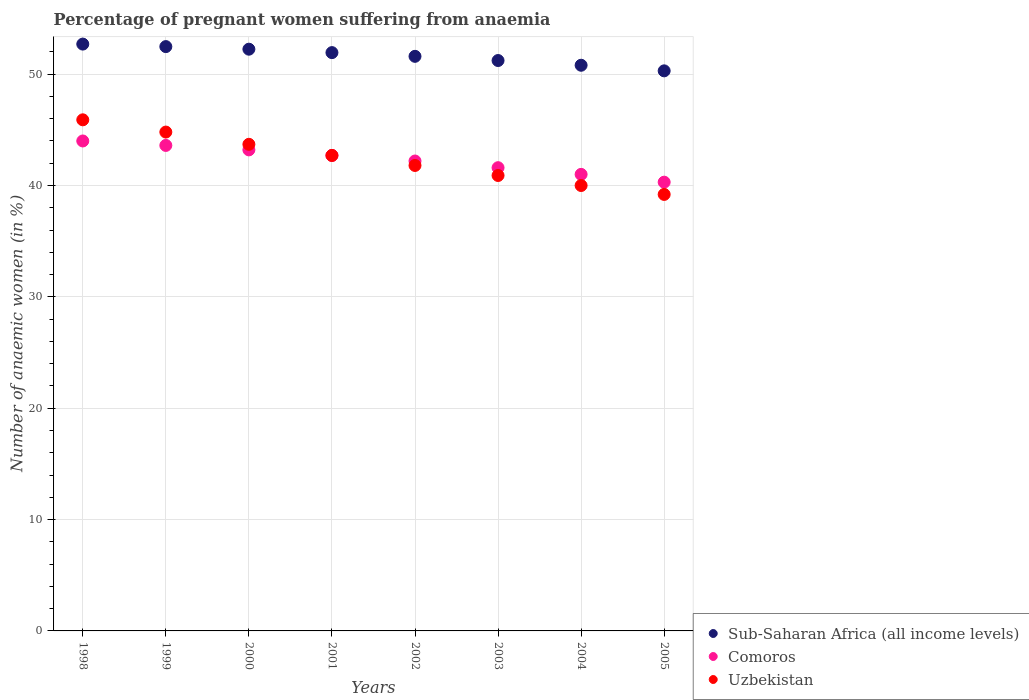What is the number of anaemic women in Comoros in 2005?
Your response must be concise. 40.3. Across all years, what is the maximum number of anaemic women in Sub-Saharan Africa (all income levels)?
Offer a very short reply. 52.7. Across all years, what is the minimum number of anaemic women in Sub-Saharan Africa (all income levels)?
Your answer should be compact. 50.3. In which year was the number of anaemic women in Comoros maximum?
Your response must be concise. 1998. What is the total number of anaemic women in Comoros in the graph?
Keep it short and to the point. 338.6. What is the difference between the number of anaemic women in Sub-Saharan Africa (all income levels) in 1999 and that in 2003?
Offer a terse response. 1.25. What is the difference between the number of anaemic women in Uzbekistan in 2003 and the number of anaemic women in Comoros in 2001?
Give a very brief answer. -1.8. What is the average number of anaemic women in Comoros per year?
Give a very brief answer. 42.33. What is the ratio of the number of anaemic women in Sub-Saharan Africa (all income levels) in 1998 to that in 1999?
Make the answer very short. 1. Is the difference between the number of anaemic women in Comoros in 1999 and 2002 greater than the difference between the number of anaemic women in Uzbekistan in 1999 and 2002?
Your response must be concise. No. What is the difference between the highest and the second highest number of anaemic women in Comoros?
Your answer should be very brief. 0.4. What is the difference between the highest and the lowest number of anaemic women in Comoros?
Offer a very short reply. 3.7. In how many years, is the number of anaemic women in Sub-Saharan Africa (all income levels) greater than the average number of anaemic women in Sub-Saharan Africa (all income levels) taken over all years?
Give a very brief answer. 4. Is it the case that in every year, the sum of the number of anaemic women in Sub-Saharan Africa (all income levels) and number of anaemic women in Uzbekistan  is greater than the number of anaemic women in Comoros?
Your answer should be compact. Yes. Does the number of anaemic women in Comoros monotonically increase over the years?
Offer a terse response. No. Is the number of anaemic women in Uzbekistan strictly less than the number of anaemic women in Comoros over the years?
Your answer should be compact. No. How many dotlines are there?
Offer a terse response. 3. How many years are there in the graph?
Give a very brief answer. 8. What is the difference between two consecutive major ticks on the Y-axis?
Provide a short and direct response. 10. Are the values on the major ticks of Y-axis written in scientific E-notation?
Make the answer very short. No. What is the title of the graph?
Your answer should be compact. Percentage of pregnant women suffering from anaemia. What is the label or title of the X-axis?
Provide a short and direct response. Years. What is the label or title of the Y-axis?
Offer a very short reply. Number of anaemic women (in %). What is the Number of anaemic women (in %) of Sub-Saharan Africa (all income levels) in 1998?
Provide a succinct answer. 52.7. What is the Number of anaemic women (in %) in Comoros in 1998?
Your response must be concise. 44. What is the Number of anaemic women (in %) in Uzbekistan in 1998?
Make the answer very short. 45.9. What is the Number of anaemic women (in %) in Sub-Saharan Africa (all income levels) in 1999?
Provide a short and direct response. 52.47. What is the Number of anaemic women (in %) in Comoros in 1999?
Your answer should be compact. 43.6. What is the Number of anaemic women (in %) of Uzbekistan in 1999?
Your answer should be very brief. 44.8. What is the Number of anaemic women (in %) of Sub-Saharan Africa (all income levels) in 2000?
Your response must be concise. 52.24. What is the Number of anaemic women (in %) of Comoros in 2000?
Your answer should be compact. 43.2. What is the Number of anaemic women (in %) of Uzbekistan in 2000?
Offer a terse response. 43.7. What is the Number of anaemic women (in %) in Sub-Saharan Africa (all income levels) in 2001?
Ensure brevity in your answer.  51.93. What is the Number of anaemic women (in %) of Comoros in 2001?
Give a very brief answer. 42.7. What is the Number of anaemic women (in %) of Uzbekistan in 2001?
Your response must be concise. 42.7. What is the Number of anaemic women (in %) of Sub-Saharan Africa (all income levels) in 2002?
Offer a very short reply. 51.6. What is the Number of anaemic women (in %) in Comoros in 2002?
Provide a short and direct response. 42.2. What is the Number of anaemic women (in %) of Uzbekistan in 2002?
Your response must be concise. 41.8. What is the Number of anaemic women (in %) of Sub-Saharan Africa (all income levels) in 2003?
Your answer should be very brief. 51.22. What is the Number of anaemic women (in %) of Comoros in 2003?
Ensure brevity in your answer.  41.6. What is the Number of anaemic women (in %) in Uzbekistan in 2003?
Offer a very short reply. 40.9. What is the Number of anaemic women (in %) in Sub-Saharan Africa (all income levels) in 2004?
Offer a terse response. 50.8. What is the Number of anaemic women (in %) of Uzbekistan in 2004?
Keep it short and to the point. 40. What is the Number of anaemic women (in %) of Sub-Saharan Africa (all income levels) in 2005?
Your answer should be compact. 50.3. What is the Number of anaemic women (in %) in Comoros in 2005?
Offer a terse response. 40.3. What is the Number of anaemic women (in %) in Uzbekistan in 2005?
Give a very brief answer. 39.2. Across all years, what is the maximum Number of anaemic women (in %) in Sub-Saharan Africa (all income levels)?
Offer a terse response. 52.7. Across all years, what is the maximum Number of anaemic women (in %) in Comoros?
Provide a short and direct response. 44. Across all years, what is the maximum Number of anaemic women (in %) in Uzbekistan?
Give a very brief answer. 45.9. Across all years, what is the minimum Number of anaemic women (in %) of Sub-Saharan Africa (all income levels)?
Keep it short and to the point. 50.3. Across all years, what is the minimum Number of anaemic women (in %) of Comoros?
Provide a succinct answer. 40.3. Across all years, what is the minimum Number of anaemic women (in %) of Uzbekistan?
Provide a short and direct response. 39.2. What is the total Number of anaemic women (in %) of Sub-Saharan Africa (all income levels) in the graph?
Offer a very short reply. 413.27. What is the total Number of anaemic women (in %) in Comoros in the graph?
Your response must be concise. 338.6. What is the total Number of anaemic women (in %) of Uzbekistan in the graph?
Keep it short and to the point. 339. What is the difference between the Number of anaemic women (in %) of Sub-Saharan Africa (all income levels) in 1998 and that in 1999?
Your answer should be compact. 0.23. What is the difference between the Number of anaemic women (in %) in Comoros in 1998 and that in 1999?
Your answer should be very brief. 0.4. What is the difference between the Number of anaemic women (in %) of Uzbekistan in 1998 and that in 1999?
Offer a very short reply. 1.1. What is the difference between the Number of anaemic women (in %) of Sub-Saharan Africa (all income levels) in 1998 and that in 2000?
Keep it short and to the point. 0.46. What is the difference between the Number of anaemic women (in %) of Uzbekistan in 1998 and that in 2000?
Offer a very short reply. 2.2. What is the difference between the Number of anaemic women (in %) of Sub-Saharan Africa (all income levels) in 1998 and that in 2001?
Your answer should be compact. 0.77. What is the difference between the Number of anaemic women (in %) in Sub-Saharan Africa (all income levels) in 1998 and that in 2002?
Keep it short and to the point. 1.1. What is the difference between the Number of anaemic women (in %) of Comoros in 1998 and that in 2002?
Make the answer very short. 1.8. What is the difference between the Number of anaemic women (in %) in Sub-Saharan Africa (all income levels) in 1998 and that in 2003?
Provide a succinct answer. 1.48. What is the difference between the Number of anaemic women (in %) in Comoros in 1998 and that in 2003?
Provide a short and direct response. 2.4. What is the difference between the Number of anaemic women (in %) of Uzbekistan in 1998 and that in 2003?
Your response must be concise. 5. What is the difference between the Number of anaemic women (in %) of Sub-Saharan Africa (all income levels) in 1998 and that in 2004?
Make the answer very short. 1.9. What is the difference between the Number of anaemic women (in %) in Comoros in 1998 and that in 2004?
Your answer should be compact. 3. What is the difference between the Number of anaemic women (in %) in Sub-Saharan Africa (all income levels) in 1998 and that in 2005?
Your answer should be compact. 2.4. What is the difference between the Number of anaemic women (in %) in Comoros in 1998 and that in 2005?
Offer a very short reply. 3.7. What is the difference between the Number of anaemic women (in %) of Sub-Saharan Africa (all income levels) in 1999 and that in 2000?
Your response must be concise. 0.23. What is the difference between the Number of anaemic women (in %) in Comoros in 1999 and that in 2000?
Your answer should be compact. 0.4. What is the difference between the Number of anaemic women (in %) of Uzbekistan in 1999 and that in 2000?
Your answer should be compact. 1.1. What is the difference between the Number of anaemic women (in %) in Sub-Saharan Africa (all income levels) in 1999 and that in 2001?
Your answer should be very brief. 0.54. What is the difference between the Number of anaemic women (in %) in Comoros in 1999 and that in 2001?
Give a very brief answer. 0.9. What is the difference between the Number of anaemic women (in %) of Sub-Saharan Africa (all income levels) in 1999 and that in 2002?
Your response must be concise. 0.87. What is the difference between the Number of anaemic women (in %) of Sub-Saharan Africa (all income levels) in 1999 and that in 2003?
Ensure brevity in your answer.  1.25. What is the difference between the Number of anaemic women (in %) of Comoros in 1999 and that in 2003?
Your answer should be compact. 2. What is the difference between the Number of anaemic women (in %) of Sub-Saharan Africa (all income levels) in 1999 and that in 2004?
Provide a short and direct response. 1.67. What is the difference between the Number of anaemic women (in %) in Comoros in 1999 and that in 2004?
Your response must be concise. 2.6. What is the difference between the Number of anaemic women (in %) of Uzbekistan in 1999 and that in 2004?
Provide a succinct answer. 4.8. What is the difference between the Number of anaemic women (in %) in Sub-Saharan Africa (all income levels) in 1999 and that in 2005?
Provide a short and direct response. 2.18. What is the difference between the Number of anaemic women (in %) of Comoros in 1999 and that in 2005?
Your response must be concise. 3.3. What is the difference between the Number of anaemic women (in %) of Uzbekistan in 1999 and that in 2005?
Provide a succinct answer. 5.6. What is the difference between the Number of anaemic women (in %) of Sub-Saharan Africa (all income levels) in 2000 and that in 2001?
Give a very brief answer. 0.31. What is the difference between the Number of anaemic women (in %) of Comoros in 2000 and that in 2001?
Your answer should be compact. 0.5. What is the difference between the Number of anaemic women (in %) of Uzbekistan in 2000 and that in 2001?
Give a very brief answer. 1. What is the difference between the Number of anaemic women (in %) of Sub-Saharan Africa (all income levels) in 2000 and that in 2002?
Provide a succinct answer. 0.64. What is the difference between the Number of anaemic women (in %) in Comoros in 2000 and that in 2002?
Provide a short and direct response. 1. What is the difference between the Number of anaemic women (in %) of Sub-Saharan Africa (all income levels) in 2000 and that in 2003?
Your answer should be very brief. 1.02. What is the difference between the Number of anaemic women (in %) in Comoros in 2000 and that in 2003?
Your answer should be very brief. 1.6. What is the difference between the Number of anaemic women (in %) of Sub-Saharan Africa (all income levels) in 2000 and that in 2004?
Your answer should be compact. 1.44. What is the difference between the Number of anaemic women (in %) in Comoros in 2000 and that in 2004?
Your answer should be compact. 2.2. What is the difference between the Number of anaemic women (in %) in Sub-Saharan Africa (all income levels) in 2000 and that in 2005?
Ensure brevity in your answer.  1.94. What is the difference between the Number of anaemic women (in %) of Sub-Saharan Africa (all income levels) in 2001 and that in 2002?
Offer a terse response. 0.33. What is the difference between the Number of anaemic women (in %) of Uzbekistan in 2001 and that in 2002?
Your answer should be very brief. 0.9. What is the difference between the Number of anaemic women (in %) in Sub-Saharan Africa (all income levels) in 2001 and that in 2003?
Give a very brief answer. 0.71. What is the difference between the Number of anaemic women (in %) of Comoros in 2001 and that in 2003?
Keep it short and to the point. 1.1. What is the difference between the Number of anaemic women (in %) of Sub-Saharan Africa (all income levels) in 2001 and that in 2004?
Your answer should be compact. 1.13. What is the difference between the Number of anaemic women (in %) of Comoros in 2001 and that in 2004?
Provide a short and direct response. 1.7. What is the difference between the Number of anaemic women (in %) in Sub-Saharan Africa (all income levels) in 2001 and that in 2005?
Your answer should be very brief. 1.64. What is the difference between the Number of anaemic women (in %) of Uzbekistan in 2001 and that in 2005?
Offer a terse response. 3.5. What is the difference between the Number of anaemic women (in %) of Sub-Saharan Africa (all income levels) in 2002 and that in 2003?
Offer a very short reply. 0.38. What is the difference between the Number of anaemic women (in %) of Uzbekistan in 2002 and that in 2003?
Your answer should be very brief. 0.9. What is the difference between the Number of anaemic women (in %) of Sub-Saharan Africa (all income levels) in 2002 and that in 2004?
Provide a short and direct response. 0.8. What is the difference between the Number of anaemic women (in %) of Uzbekistan in 2002 and that in 2004?
Keep it short and to the point. 1.8. What is the difference between the Number of anaemic women (in %) of Sub-Saharan Africa (all income levels) in 2002 and that in 2005?
Give a very brief answer. 1.3. What is the difference between the Number of anaemic women (in %) in Comoros in 2002 and that in 2005?
Provide a succinct answer. 1.9. What is the difference between the Number of anaemic women (in %) of Sub-Saharan Africa (all income levels) in 2003 and that in 2004?
Make the answer very short. 0.42. What is the difference between the Number of anaemic women (in %) of Uzbekistan in 2003 and that in 2004?
Your answer should be very brief. 0.9. What is the difference between the Number of anaemic women (in %) of Sub-Saharan Africa (all income levels) in 2003 and that in 2005?
Offer a terse response. 0.93. What is the difference between the Number of anaemic women (in %) of Uzbekistan in 2003 and that in 2005?
Your answer should be very brief. 1.7. What is the difference between the Number of anaemic women (in %) in Sub-Saharan Africa (all income levels) in 2004 and that in 2005?
Give a very brief answer. 0.5. What is the difference between the Number of anaemic women (in %) of Sub-Saharan Africa (all income levels) in 1998 and the Number of anaemic women (in %) of Comoros in 1999?
Ensure brevity in your answer.  9.1. What is the difference between the Number of anaemic women (in %) of Sub-Saharan Africa (all income levels) in 1998 and the Number of anaemic women (in %) of Uzbekistan in 1999?
Your response must be concise. 7.9. What is the difference between the Number of anaemic women (in %) in Comoros in 1998 and the Number of anaemic women (in %) in Uzbekistan in 1999?
Offer a terse response. -0.8. What is the difference between the Number of anaemic women (in %) of Sub-Saharan Africa (all income levels) in 1998 and the Number of anaemic women (in %) of Comoros in 2000?
Your response must be concise. 9.5. What is the difference between the Number of anaemic women (in %) of Sub-Saharan Africa (all income levels) in 1998 and the Number of anaemic women (in %) of Uzbekistan in 2000?
Your answer should be very brief. 9. What is the difference between the Number of anaemic women (in %) in Sub-Saharan Africa (all income levels) in 1998 and the Number of anaemic women (in %) in Comoros in 2001?
Your response must be concise. 10. What is the difference between the Number of anaemic women (in %) of Sub-Saharan Africa (all income levels) in 1998 and the Number of anaemic women (in %) of Uzbekistan in 2001?
Keep it short and to the point. 10. What is the difference between the Number of anaemic women (in %) in Comoros in 1998 and the Number of anaemic women (in %) in Uzbekistan in 2001?
Keep it short and to the point. 1.3. What is the difference between the Number of anaemic women (in %) in Sub-Saharan Africa (all income levels) in 1998 and the Number of anaemic women (in %) in Comoros in 2002?
Your answer should be very brief. 10.5. What is the difference between the Number of anaemic women (in %) of Sub-Saharan Africa (all income levels) in 1998 and the Number of anaemic women (in %) of Uzbekistan in 2002?
Make the answer very short. 10.9. What is the difference between the Number of anaemic women (in %) of Comoros in 1998 and the Number of anaemic women (in %) of Uzbekistan in 2002?
Your answer should be compact. 2.2. What is the difference between the Number of anaemic women (in %) of Sub-Saharan Africa (all income levels) in 1998 and the Number of anaemic women (in %) of Comoros in 2003?
Offer a terse response. 11.1. What is the difference between the Number of anaemic women (in %) of Sub-Saharan Africa (all income levels) in 1998 and the Number of anaemic women (in %) of Uzbekistan in 2003?
Provide a short and direct response. 11.8. What is the difference between the Number of anaemic women (in %) in Sub-Saharan Africa (all income levels) in 1998 and the Number of anaemic women (in %) in Comoros in 2004?
Your answer should be very brief. 11.7. What is the difference between the Number of anaemic women (in %) of Sub-Saharan Africa (all income levels) in 1998 and the Number of anaemic women (in %) of Uzbekistan in 2004?
Your answer should be compact. 12.7. What is the difference between the Number of anaemic women (in %) of Comoros in 1998 and the Number of anaemic women (in %) of Uzbekistan in 2004?
Ensure brevity in your answer.  4. What is the difference between the Number of anaemic women (in %) in Sub-Saharan Africa (all income levels) in 1998 and the Number of anaemic women (in %) in Comoros in 2005?
Provide a succinct answer. 12.4. What is the difference between the Number of anaemic women (in %) of Sub-Saharan Africa (all income levels) in 1998 and the Number of anaemic women (in %) of Uzbekistan in 2005?
Make the answer very short. 13.5. What is the difference between the Number of anaemic women (in %) in Sub-Saharan Africa (all income levels) in 1999 and the Number of anaemic women (in %) in Comoros in 2000?
Provide a succinct answer. 9.27. What is the difference between the Number of anaemic women (in %) of Sub-Saharan Africa (all income levels) in 1999 and the Number of anaemic women (in %) of Uzbekistan in 2000?
Ensure brevity in your answer.  8.77. What is the difference between the Number of anaemic women (in %) in Sub-Saharan Africa (all income levels) in 1999 and the Number of anaemic women (in %) in Comoros in 2001?
Provide a succinct answer. 9.77. What is the difference between the Number of anaemic women (in %) of Sub-Saharan Africa (all income levels) in 1999 and the Number of anaemic women (in %) of Uzbekistan in 2001?
Your answer should be compact. 9.77. What is the difference between the Number of anaemic women (in %) in Comoros in 1999 and the Number of anaemic women (in %) in Uzbekistan in 2001?
Give a very brief answer. 0.9. What is the difference between the Number of anaemic women (in %) of Sub-Saharan Africa (all income levels) in 1999 and the Number of anaemic women (in %) of Comoros in 2002?
Offer a very short reply. 10.27. What is the difference between the Number of anaemic women (in %) of Sub-Saharan Africa (all income levels) in 1999 and the Number of anaemic women (in %) of Uzbekistan in 2002?
Your answer should be compact. 10.67. What is the difference between the Number of anaemic women (in %) of Sub-Saharan Africa (all income levels) in 1999 and the Number of anaemic women (in %) of Comoros in 2003?
Ensure brevity in your answer.  10.87. What is the difference between the Number of anaemic women (in %) in Sub-Saharan Africa (all income levels) in 1999 and the Number of anaemic women (in %) in Uzbekistan in 2003?
Your response must be concise. 11.57. What is the difference between the Number of anaemic women (in %) in Sub-Saharan Africa (all income levels) in 1999 and the Number of anaemic women (in %) in Comoros in 2004?
Ensure brevity in your answer.  11.47. What is the difference between the Number of anaemic women (in %) in Sub-Saharan Africa (all income levels) in 1999 and the Number of anaemic women (in %) in Uzbekistan in 2004?
Offer a terse response. 12.47. What is the difference between the Number of anaemic women (in %) of Comoros in 1999 and the Number of anaemic women (in %) of Uzbekistan in 2004?
Offer a very short reply. 3.6. What is the difference between the Number of anaemic women (in %) in Sub-Saharan Africa (all income levels) in 1999 and the Number of anaemic women (in %) in Comoros in 2005?
Provide a short and direct response. 12.17. What is the difference between the Number of anaemic women (in %) of Sub-Saharan Africa (all income levels) in 1999 and the Number of anaemic women (in %) of Uzbekistan in 2005?
Your answer should be very brief. 13.27. What is the difference between the Number of anaemic women (in %) in Comoros in 1999 and the Number of anaemic women (in %) in Uzbekistan in 2005?
Your response must be concise. 4.4. What is the difference between the Number of anaemic women (in %) in Sub-Saharan Africa (all income levels) in 2000 and the Number of anaemic women (in %) in Comoros in 2001?
Make the answer very short. 9.54. What is the difference between the Number of anaemic women (in %) in Sub-Saharan Africa (all income levels) in 2000 and the Number of anaemic women (in %) in Uzbekistan in 2001?
Provide a succinct answer. 9.54. What is the difference between the Number of anaemic women (in %) in Comoros in 2000 and the Number of anaemic women (in %) in Uzbekistan in 2001?
Offer a terse response. 0.5. What is the difference between the Number of anaemic women (in %) of Sub-Saharan Africa (all income levels) in 2000 and the Number of anaemic women (in %) of Comoros in 2002?
Offer a terse response. 10.04. What is the difference between the Number of anaemic women (in %) of Sub-Saharan Africa (all income levels) in 2000 and the Number of anaemic women (in %) of Uzbekistan in 2002?
Make the answer very short. 10.44. What is the difference between the Number of anaemic women (in %) of Comoros in 2000 and the Number of anaemic women (in %) of Uzbekistan in 2002?
Offer a terse response. 1.4. What is the difference between the Number of anaemic women (in %) of Sub-Saharan Africa (all income levels) in 2000 and the Number of anaemic women (in %) of Comoros in 2003?
Offer a very short reply. 10.64. What is the difference between the Number of anaemic women (in %) of Sub-Saharan Africa (all income levels) in 2000 and the Number of anaemic women (in %) of Uzbekistan in 2003?
Keep it short and to the point. 11.34. What is the difference between the Number of anaemic women (in %) of Sub-Saharan Africa (all income levels) in 2000 and the Number of anaemic women (in %) of Comoros in 2004?
Ensure brevity in your answer.  11.24. What is the difference between the Number of anaemic women (in %) of Sub-Saharan Africa (all income levels) in 2000 and the Number of anaemic women (in %) of Uzbekistan in 2004?
Offer a terse response. 12.24. What is the difference between the Number of anaemic women (in %) in Comoros in 2000 and the Number of anaemic women (in %) in Uzbekistan in 2004?
Provide a succinct answer. 3.2. What is the difference between the Number of anaemic women (in %) of Sub-Saharan Africa (all income levels) in 2000 and the Number of anaemic women (in %) of Comoros in 2005?
Your answer should be very brief. 11.94. What is the difference between the Number of anaemic women (in %) of Sub-Saharan Africa (all income levels) in 2000 and the Number of anaemic women (in %) of Uzbekistan in 2005?
Offer a very short reply. 13.04. What is the difference between the Number of anaemic women (in %) of Sub-Saharan Africa (all income levels) in 2001 and the Number of anaemic women (in %) of Comoros in 2002?
Give a very brief answer. 9.73. What is the difference between the Number of anaemic women (in %) of Sub-Saharan Africa (all income levels) in 2001 and the Number of anaemic women (in %) of Uzbekistan in 2002?
Give a very brief answer. 10.13. What is the difference between the Number of anaemic women (in %) of Comoros in 2001 and the Number of anaemic women (in %) of Uzbekistan in 2002?
Ensure brevity in your answer.  0.9. What is the difference between the Number of anaemic women (in %) in Sub-Saharan Africa (all income levels) in 2001 and the Number of anaemic women (in %) in Comoros in 2003?
Give a very brief answer. 10.33. What is the difference between the Number of anaemic women (in %) in Sub-Saharan Africa (all income levels) in 2001 and the Number of anaemic women (in %) in Uzbekistan in 2003?
Provide a succinct answer. 11.03. What is the difference between the Number of anaemic women (in %) in Comoros in 2001 and the Number of anaemic women (in %) in Uzbekistan in 2003?
Make the answer very short. 1.8. What is the difference between the Number of anaemic women (in %) of Sub-Saharan Africa (all income levels) in 2001 and the Number of anaemic women (in %) of Comoros in 2004?
Provide a short and direct response. 10.93. What is the difference between the Number of anaemic women (in %) in Sub-Saharan Africa (all income levels) in 2001 and the Number of anaemic women (in %) in Uzbekistan in 2004?
Provide a short and direct response. 11.93. What is the difference between the Number of anaemic women (in %) of Sub-Saharan Africa (all income levels) in 2001 and the Number of anaemic women (in %) of Comoros in 2005?
Provide a succinct answer. 11.63. What is the difference between the Number of anaemic women (in %) of Sub-Saharan Africa (all income levels) in 2001 and the Number of anaemic women (in %) of Uzbekistan in 2005?
Keep it short and to the point. 12.73. What is the difference between the Number of anaemic women (in %) of Sub-Saharan Africa (all income levels) in 2002 and the Number of anaemic women (in %) of Comoros in 2003?
Your answer should be compact. 10. What is the difference between the Number of anaemic women (in %) in Sub-Saharan Africa (all income levels) in 2002 and the Number of anaemic women (in %) in Uzbekistan in 2003?
Provide a short and direct response. 10.7. What is the difference between the Number of anaemic women (in %) of Comoros in 2002 and the Number of anaemic women (in %) of Uzbekistan in 2003?
Give a very brief answer. 1.3. What is the difference between the Number of anaemic women (in %) of Sub-Saharan Africa (all income levels) in 2002 and the Number of anaemic women (in %) of Comoros in 2004?
Your answer should be very brief. 10.6. What is the difference between the Number of anaemic women (in %) of Sub-Saharan Africa (all income levels) in 2002 and the Number of anaemic women (in %) of Uzbekistan in 2004?
Make the answer very short. 11.6. What is the difference between the Number of anaemic women (in %) in Sub-Saharan Africa (all income levels) in 2002 and the Number of anaemic women (in %) in Comoros in 2005?
Provide a short and direct response. 11.3. What is the difference between the Number of anaemic women (in %) in Sub-Saharan Africa (all income levels) in 2002 and the Number of anaemic women (in %) in Uzbekistan in 2005?
Ensure brevity in your answer.  12.4. What is the difference between the Number of anaemic women (in %) of Comoros in 2002 and the Number of anaemic women (in %) of Uzbekistan in 2005?
Provide a succinct answer. 3. What is the difference between the Number of anaemic women (in %) of Sub-Saharan Africa (all income levels) in 2003 and the Number of anaemic women (in %) of Comoros in 2004?
Keep it short and to the point. 10.22. What is the difference between the Number of anaemic women (in %) of Sub-Saharan Africa (all income levels) in 2003 and the Number of anaemic women (in %) of Uzbekistan in 2004?
Offer a very short reply. 11.22. What is the difference between the Number of anaemic women (in %) of Comoros in 2003 and the Number of anaemic women (in %) of Uzbekistan in 2004?
Offer a terse response. 1.6. What is the difference between the Number of anaemic women (in %) in Sub-Saharan Africa (all income levels) in 2003 and the Number of anaemic women (in %) in Comoros in 2005?
Provide a short and direct response. 10.92. What is the difference between the Number of anaemic women (in %) in Sub-Saharan Africa (all income levels) in 2003 and the Number of anaemic women (in %) in Uzbekistan in 2005?
Provide a succinct answer. 12.02. What is the difference between the Number of anaemic women (in %) in Sub-Saharan Africa (all income levels) in 2004 and the Number of anaemic women (in %) in Comoros in 2005?
Provide a short and direct response. 10.5. What is the difference between the Number of anaemic women (in %) of Sub-Saharan Africa (all income levels) in 2004 and the Number of anaemic women (in %) of Uzbekistan in 2005?
Provide a succinct answer. 11.6. What is the difference between the Number of anaemic women (in %) of Comoros in 2004 and the Number of anaemic women (in %) of Uzbekistan in 2005?
Keep it short and to the point. 1.8. What is the average Number of anaemic women (in %) in Sub-Saharan Africa (all income levels) per year?
Your response must be concise. 51.66. What is the average Number of anaemic women (in %) in Comoros per year?
Provide a short and direct response. 42.33. What is the average Number of anaemic women (in %) in Uzbekistan per year?
Your answer should be compact. 42.38. In the year 1998, what is the difference between the Number of anaemic women (in %) in Sub-Saharan Africa (all income levels) and Number of anaemic women (in %) in Comoros?
Make the answer very short. 8.7. In the year 1998, what is the difference between the Number of anaemic women (in %) in Sub-Saharan Africa (all income levels) and Number of anaemic women (in %) in Uzbekistan?
Ensure brevity in your answer.  6.8. In the year 1999, what is the difference between the Number of anaemic women (in %) of Sub-Saharan Africa (all income levels) and Number of anaemic women (in %) of Comoros?
Provide a short and direct response. 8.87. In the year 1999, what is the difference between the Number of anaemic women (in %) of Sub-Saharan Africa (all income levels) and Number of anaemic women (in %) of Uzbekistan?
Ensure brevity in your answer.  7.67. In the year 1999, what is the difference between the Number of anaemic women (in %) in Comoros and Number of anaemic women (in %) in Uzbekistan?
Provide a short and direct response. -1.2. In the year 2000, what is the difference between the Number of anaemic women (in %) of Sub-Saharan Africa (all income levels) and Number of anaemic women (in %) of Comoros?
Offer a very short reply. 9.04. In the year 2000, what is the difference between the Number of anaemic women (in %) of Sub-Saharan Africa (all income levels) and Number of anaemic women (in %) of Uzbekistan?
Offer a terse response. 8.54. In the year 2000, what is the difference between the Number of anaemic women (in %) of Comoros and Number of anaemic women (in %) of Uzbekistan?
Your answer should be compact. -0.5. In the year 2001, what is the difference between the Number of anaemic women (in %) of Sub-Saharan Africa (all income levels) and Number of anaemic women (in %) of Comoros?
Offer a very short reply. 9.23. In the year 2001, what is the difference between the Number of anaemic women (in %) in Sub-Saharan Africa (all income levels) and Number of anaemic women (in %) in Uzbekistan?
Your response must be concise. 9.23. In the year 2002, what is the difference between the Number of anaemic women (in %) in Sub-Saharan Africa (all income levels) and Number of anaemic women (in %) in Comoros?
Provide a short and direct response. 9.4. In the year 2002, what is the difference between the Number of anaemic women (in %) of Sub-Saharan Africa (all income levels) and Number of anaemic women (in %) of Uzbekistan?
Make the answer very short. 9.8. In the year 2002, what is the difference between the Number of anaemic women (in %) of Comoros and Number of anaemic women (in %) of Uzbekistan?
Ensure brevity in your answer.  0.4. In the year 2003, what is the difference between the Number of anaemic women (in %) in Sub-Saharan Africa (all income levels) and Number of anaemic women (in %) in Comoros?
Make the answer very short. 9.62. In the year 2003, what is the difference between the Number of anaemic women (in %) in Sub-Saharan Africa (all income levels) and Number of anaemic women (in %) in Uzbekistan?
Provide a succinct answer. 10.32. In the year 2004, what is the difference between the Number of anaemic women (in %) of Sub-Saharan Africa (all income levels) and Number of anaemic women (in %) of Comoros?
Make the answer very short. 9.8. In the year 2004, what is the difference between the Number of anaemic women (in %) in Sub-Saharan Africa (all income levels) and Number of anaemic women (in %) in Uzbekistan?
Provide a short and direct response. 10.8. In the year 2004, what is the difference between the Number of anaemic women (in %) of Comoros and Number of anaemic women (in %) of Uzbekistan?
Provide a succinct answer. 1. In the year 2005, what is the difference between the Number of anaemic women (in %) of Sub-Saharan Africa (all income levels) and Number of anaemic women (in %) of Comoros?
Your response must be concise. 10. In the year 2005, what is the difference between the Number of anaemic women (in %) in Sub-Saharan Africa (all income levels) and Number of anaemic women (in %) in Uzbekistan?
Make the answer very short. 11.1. In the year 2005, what is the difference between the Number of anaemic women (in %) of Comoros and Number of anaemic women (in %) of Uzbekistan?
Provide a succinct answer. 1.1. What is the ratio of the Number of anaemic women (in %) in Comoros in 1998 to that in 1999?
Give a very brief answer. 1.01. What is the ratio of the Number of anaemic women (in %) of Uzbekistan in 1998 to that in 1999?
Offer a terse response. 1.02. What is the ratio of the Number of anaemic women (in %) in Sub-Saharan Africa (all income levels) in 1998 to that in 2000?
Your answer should be very brief. 1.01. What is the ratio of the Number of anaemic women (in %) of Comoros in 1998 to that in 2000?
Keep it short and to the point. 1.02. What is the ratio of the Number of anaemic women (in %) of Uzbekistan in 1998 to that in 2000?
Give a very brief answer. 1.05. What is the ratio of the Number of anaemic women (in %) of Sub-Saharan Africa (all income levels) in 1998 to that in 2001?
Offer a very short reply. 1.01. What is the ratio of the Number of anaemic women (in %) in Comoros in 1998 to that in 2001?
Your response must be concise. 1.03. What is the ratio of the Number of anaemic women (in %) of Uzbekistan in 1998 to that in 2001?
Make the answer very short. 1.07. What is the ratio of the Number of anaemic women (in %) of Sub-Saharan Africa (all income levels) in 1998 to that in 2002?
Your answer should be very brief. 1.02. What is the ratio of the Number of anaemic women (in %) of Comoros in 1998 to that in 2002?
Your answer should be compact. 1.04. What is the ratio of the Number of anaemic women (in %) of Uzbekistan in 1998 to that in 2002?
Give a very brief answer. 1.1. What is the ratio of the Number of anaemic women (in %) of Sub-Saharan Africa (all income levels) in 1998 to that in 2003?
Offer a terse response. 1.03. What is the ratio of the Number of anaemic women (in %) in Comoros in 1998 to that in 2003?
Your response must be concise. 1.06. What is the ratio of the Number of anaemic women (in %) in Uzbekistan in 1998 to that in 2003?
Your answer should be very brief. 1.12. What is the ratio of the Number of anaemic women (in %) of Sub-Saharan Africa (all income levels) in 1998 to that in 2004?
Your answer should be compact. 1.04. What is the ratio of the Number of anaemic women (in %) of Comoros in 1998 to that in 2004?
Keep it short and to the point. 1.07. What is the ratio of the Number of anaemic women (in %) in Uzbekistan in 1998 to that in 2004?
Keep it short and to the point. 1.15. What is the ratio of the Number of anaemic women (in %) of Sub-Saharan Africa (all income levels) in 1998 to that in 2005?
Your answer should be very brief. 1.05. What is the ratio of the Number of anaemic women (in %) of Comoros in 1998 to that in 2005?
Provide a succinct answer. 1.09. What is the ratio of the Number of anaemic women (in %) in Uzbekistan in 1998 to that in 2005?
Your answer should be very brief. 1.17. What is the ratio of the Number of anaemic women (in %) in Sub-Saharan Africa (all income levels) in 1999 to that in 2000?
Ensure brevity in your answer.  1. What is the ratio of the Number of anaemic women (in %) of Comoros in 1999 to that in 2000?
Provide a succinct answer. 1.01. What is the ratio of the Number of anaemic women (in %) in Uzbekistan in 1999 to that in 2000?
Offer a very short reply. 1.03. What is the ratio of the Number of anaemic women (in %) of Sub-Saharan Africa (all income levels) in 1999 to that in 2001?
Make the answer very short. 1.01. What is the ratio of the Number of anaemic women (in %) in Comoros in 1999 to that in 2001?
Your answer should be very brief. 1.02. What is the ratio of the Number of anaemic women (in %) in Uzbekistan in 1999 to that in 2001?
Give a very brief answer. 1.05. What is the ratio of the Number of anaemic women (in %) in Sub-Saharan Africa (all income levels) in 1999 to that in 2002?
Your answer should be very brief. 1.02. What is the ratio of the Number of anaemic women (in %) of Comoros in 1999 to that in 2002?
Your answer should be compact. 1.03. What is the ratio of the Number of anaemic women (in %) in Uzbekistan in 1999 to that in 2002?
Offer a very short reply. 1.07. What is the ratio of the Number of anaemic women (in %) of Sub-Saharan Africa (all income levels) in 1999 to that in 2003?
Provide a succinct answer. 1.02. What is the ratio of the Number of anaemic women (in %) of Comoros in 1999 to that in 2003?
Give a very brief answer. 1.05. What is the ratio of the Number of anaemic women (in %) in Uzbekistan in 1999 to that in 2003?
Your answer should be compact. 1.1. What is the ratio of the Number of anaemic women (in %) of Sub-Saharan Africa (all income levels) in 1999 to that in 2004?
Offer a terse response. 1.03. What is the ratio of the Number of anaemic women (in %) in Comoros in 1999 to that in 2004?
Your response must be concise. 1.06. What is the ratio of the Number of anaemic women (in %) of Uzbekistan in 1999 to that in 2004?
Provide a succinct answer. 1.12. What is the ratio of the Number of anaemic women (in %) of Sub-Saharan Africa (all income levels) in 1999 to that in 2005?
Your answer should be compact. 1.04. What is the ratio of the Number of anaemic women (in %) in Comoros in 1999 to that in 2005?
Provide a succinct answer. 1.08. What is the ratio of the Number of anaemic women (in %) in Sub-Saharan Africa (all income levels) in 2000 to that in 2001?
Offer a terse response. 1.01. What is the ratio of the Number of anaemic women (in %) in Comoros in 2000 to that in 2001?
Your response must be concise. 1.01. What is the ratio of the Number of anaemic women (in %) of Uzbekistan in 2000 to that in 2001?
Offer a terse response. 1.02. What is the ratio of the Number of anaemic women (in %) of Sub-Saharan Africa (all income levels) in 2000 to that in 2002?
Your answer should be compact. 1.01. What is the ratio of the Number of anaemic women (in %) in Comoros in 2000 to that in 2002?
Provide a short and direct response. 1.02. What is the ratio of the Number of anaemic women (in %) of Uzbekistan in 2000 to that in 2002?
Give a very brief answer. 1.05. What is the ratio of the Number of anaemic women (in %) in Sub-Saharan Africa (all income levels) in 2000 to that in 2003?
Provide a short and direct response. 1.02. What is the ratio of the Number of anaemic women (in %) of Comoros in 2000 to that in 2003?
Your response must be concise. 1.04. What is the ratio of the Number of anaemic women (in %) of Uzbekistan in 2000 to that in 2003?
Your answer should be very brief. 1.07. What is the ratio of the Number of anaemic women (in %) of Sub-Saharan Africa (all income levels) in 2000 to that in 2004?
Make the answer very short. 1.03. What is the ratio of the Number of anaemic women (in %) of Comoros in 2000 to that in 2004?
Give a very brief answer. 1.05. What is the ratio of the Number of anaemic women (in %) in Uzbekistan in 2000 to that in 2004?
Your response must be concise. 1.09. What is the ratio of the Number of anaemic women (in %) of Sub-Saharan Africa (all income levels) in 2000 to that in 2005?
Offer a very short reply. 1.04. What is the ratio of the Number of anaemic women (in %) in Comoros in 2000 to that in 2005?
Provide a succinct answer. 1.07. What is the ratio of the Number of anaemic women (in %) in Uzbekistan in 2000 to that in 2005?
Ensure brevity in your answer.  1.11. What is the ratio of the Number of anaemic women (in %) in Comoros in 2001 to that in 2002?
Make the answer very short. 1.01. What is the ratio of the Number of anaemic women (in %) in Uzbekistan in 2001 to that in 2002?
Give a very brief answer. 1.02. What is the ratio of the Number of anaemic women (in %) in Sub-Saharan Africa (all income levels) in 2001 to that in 2003?
Offer a terse response. 1.01. What is the ratio of the Number of anaemic women (in %) in Comoros in 2001 to that in 2003?
Offer a very short reply. 1.03. What is the ratio of the Number of anaemic women (in %) in Uzbekistan in 2001 to that in 2003?
Offer a very short reply. 1.04. What is the ratio of the Number of anaemic women (in %) in Sub-Saharan Africa (all income levels) in 2001 to that in 2004?
Give a very brief answer. 1.02. What is the ratio of the Number of anaemic women (in %) of Comoros in 2001 to that in 2004?
Make the answer very short. 1.04. What is the ratio of the Number of anaemic women (in %) in Uzbekistan in 2001 to that in 2004?
Provide a succinct answer. 1.07. What is the ratio of the Number of anaemic women (in %) of Sub-Saharan Africa (all income levels) in 2001 to that in 2005?
Offer a very short reply. 1.03. What is the ratio of the Number of anaemic women (in %) in Comoros in 2001 to that in 2005?
Your answer should be compact. 1.06. What is the ratio of the Number of anaemic women (in %) of Uzbekistan in 2001 to that in 2005?
Keep it short and to the point. 1.09. What is the ratio of the Number of anaemic women (in %) of Sub-Saharan Africa (all income levels) in 2002 to that in 2003?
Ensure brevity in your answer.  1.01. What is the ratio of the Number of anaemic women (in %) in Comoros in 2002 to that in 2003?
Provide a succinct answer. 1.01. What is the ratio of the Number of anaemic women (in %) in Uzbekistan in 2002 to that in 2003?
Offer a very short reply. 1.02. What is the ratio of the Number of anaemic women (in %) of Sub-Saharan Africa (all income levels) in 2002 to that in 2004?
Your answer should be compact. 1.02. What is the ratio of the Number of anaemic women (in %) in Comoros in 2002 to that in 2004?
Your response must be concise. 1.03. What is the ratio of the Number of anaemic women (in %) of Uzbekistan in 2002 to that in 2004?
Your answer should be compact. 1.04. What is the ratio of the Number of anaemic women (in %) in Sub-Saharan Africa (all income levels) in 2002 to that in 2005?
Offer a terse response. 1.03. What is the ratio of the Number of anaemic women (in %) of Comoros in 2002 to that in 2005?
Offer a terse response. 1.05. What is the ratio of the Number of anaemic women (in %) of Uzbekistan in 2002 to that in 2005?
Your response must be concise. 1.07. What is the ratio of the Number of anaemic women (in %) in Sub-Saharan Africa (all income levels) in 2003 to that in 2004?
Your answer should be compact. 1.01. What is the ratio of the Number of anaemic women (in %) of Comoros in 2003 to that in 2004?
Provide a short and direct response. 1.01. What is the ratio of the Number of anaemic women (in %) in Uzbekistan in 2003 to that in 2004?
Offer a terse response. 1.02. What is the ratio of the Number of anaemic women (in %) of Sub-Saharan Africa (all income levels) in 2003 to that in 2005?
Your answer should be very brief. 1.02. What is the ratio of the Number of anaemic women (in %) in Comoros in 2003 to that in 2005?
Keep it short and to the point. 1.03. What is the ratio of the Number of anaemic women (in %) in Uzbekistan in 2003 to that in 2005?
Offer a very short reply. 1.04. What is the ratio of the Number of anaemic women (in %) of Sub-Saharan Africa (all income levels) in 2004 to that in 2005?
Your response must be concise. 1.01. What is the ratio of the Number of anaemic women (in %) in Comoros in 2004 to that in 2005?
Provide a succinct answer. 1.02. What is the ratio of the Number of anaemic women (in %) of Uzbekistan in 2004 to that in 2005?
Make the answer very short. 1.02. What is the difference between the highest and the second highest Number of anaemic women (in %) of Sub-Saharan Africa (all income levels)?
Your response must be concise. 0.23. What is the difference between the highest and the second highest Number of anaemic women (in %) of Comoros?
Your answer should be very brief. 0.4. What is the difference between the highest and the second highest Number of anaemic women (in %) of Uzbekistan?
Offer a very short reply. 1.1. What is the difference between the highest and the lowest Number of anaemic women (in %) in Sub-Saharan Africa (all income levels)?
Provide a succinct answer. 2.4. What is the difference between the highest and the lowest Number of anaemic women (in %) of Comoros?
Your response must be concise. 3.7. What is the difference between the highest and the lowest Number of anaemic women (in %) in Uzbekistan?
Your answer should be compact. 6.7. 